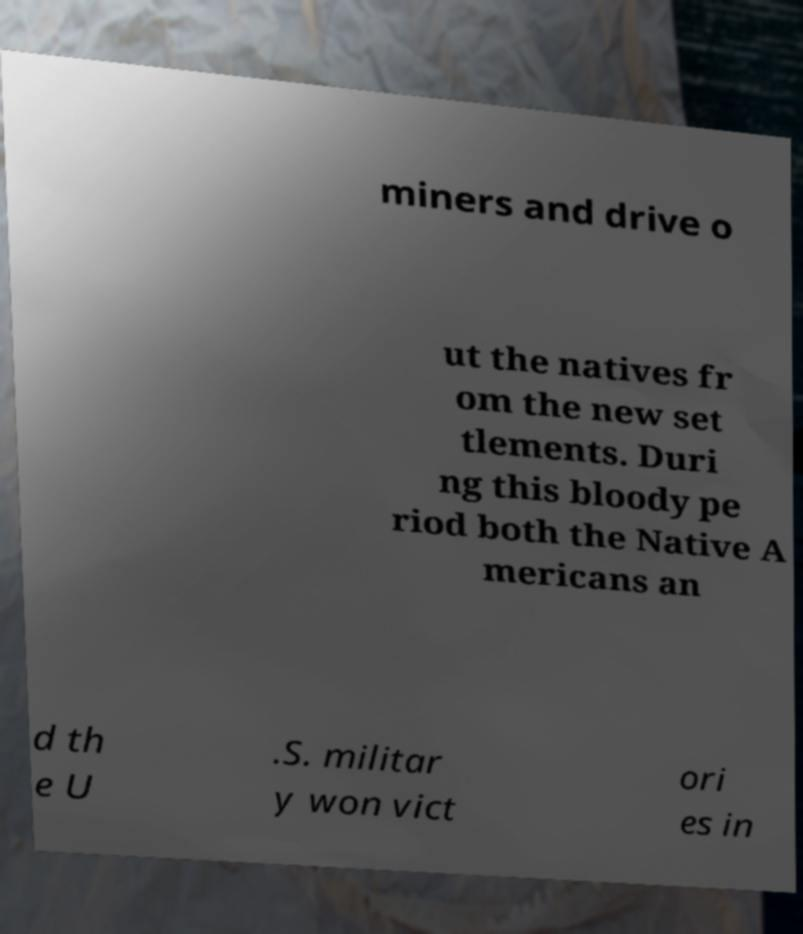Can you accurately transcribe the text from the provided image for me? miners and drive o ut the natives fr om the new set tlements. Duri ng this bloody pe riod both the Native A mericans an d th e U .S. militar y won vict ori es in 